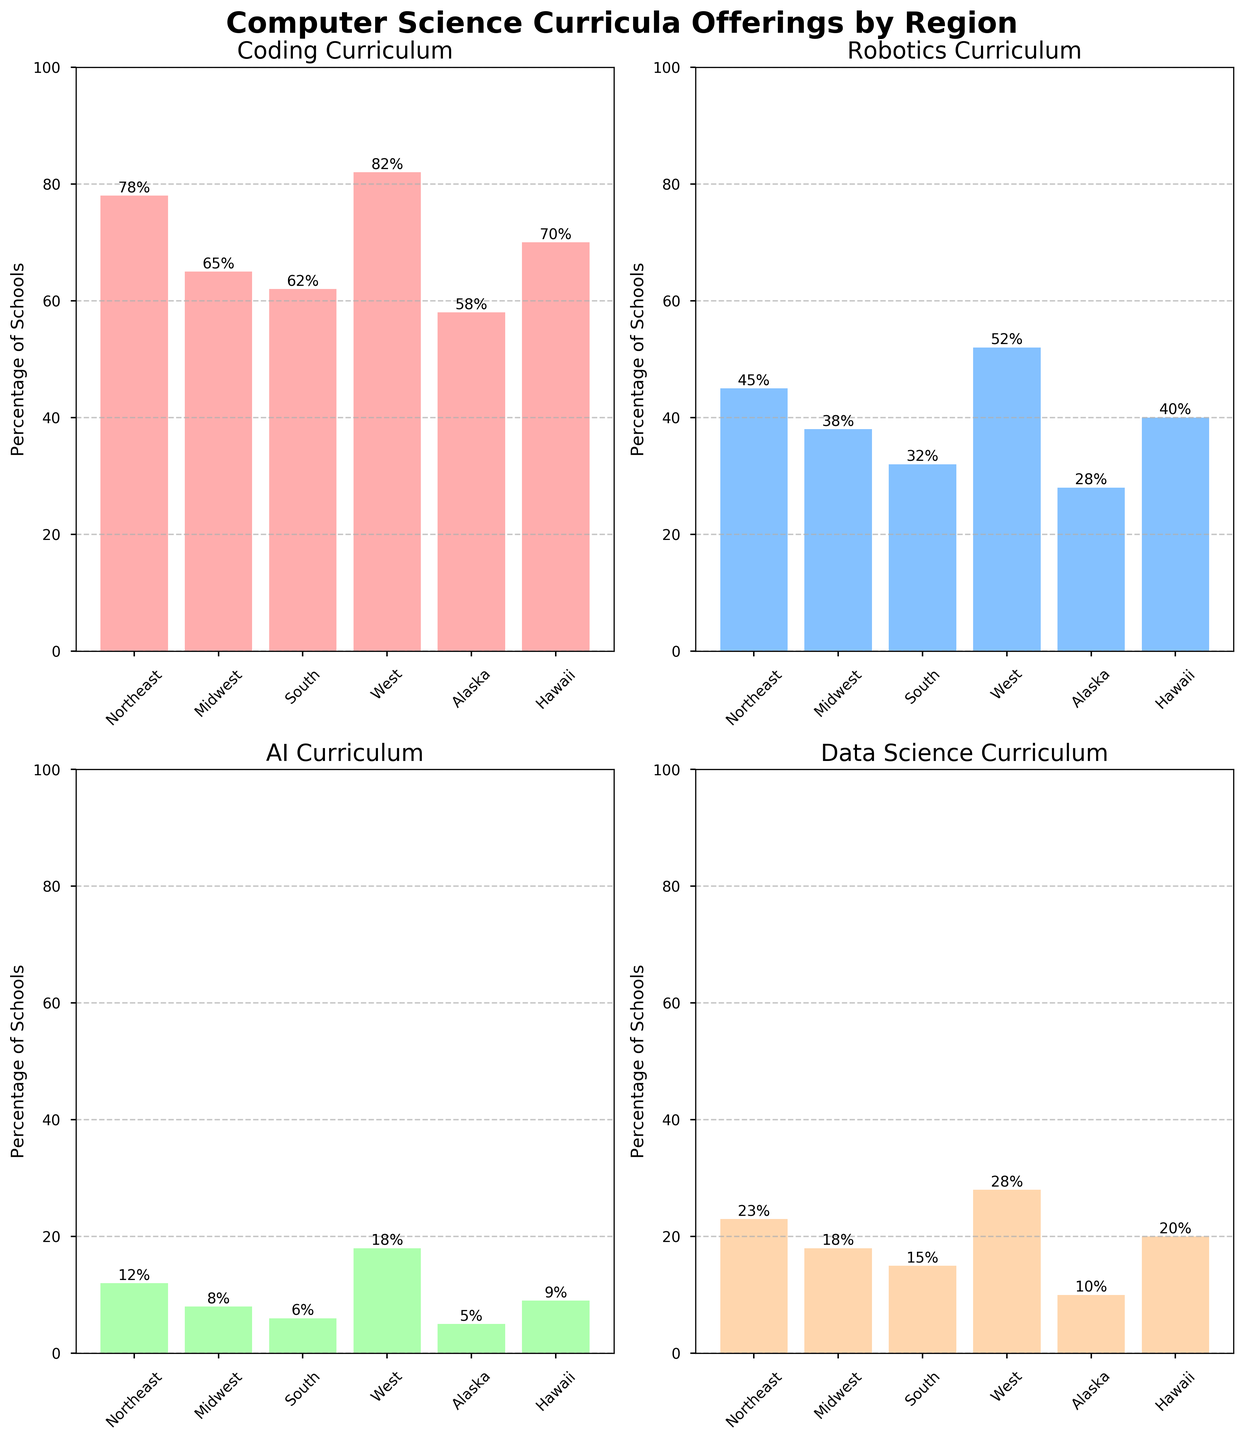What's the title of the figure? The title of the figure is usually found at the top center, often in a larger and bold font. In this specific figure, the title is "Computer Science Curricula Offerings by Region".
Answer: Computer Science Curricula Offerings by Region What percentage of schools in the West offer AI curricula? Identify the bar corresponding to the West region in the AI subplot and read the height of the bar, which represents the percentage. The bar reaches up to 18%.
Answer: 18% Which region has the highest percentage of schools offering Coding curricula? Compare the heights of the bars in the Coding subplot for all regions. The West region has the tallest bar at 82%.
Answer: West What is the difference in percentage of schools offering Robotics curricula between the West and Alaska? Identify the Robotics percentages for the West (52%) and Alaska (28%) regions, then subtract the smaller value from the larger one. 52% - 28% = 24%.
Answer: 24% Which curriculum has the least percentage of schools offering it in the South region? Compare the percentages in the South region across all subplots. AI has the lowest percentage at 6%.
Answer: AI How many curricula are offered by more than 70% of schools in the West region? Check the West region percentages across all subplots. Both Coding (82%) and Data Science (28%) surpass 70%. So only Coding.
Answer: 1 Which regions offer Data Science curricula in less than 20% of schools? Identify which regions have percentages below 20% in the Data Science subplot: Midwest (18%), South (15%), Alaska (10%), and Hawaii (20%) just on the border. Hence, Alaska, Midwest, and South.
Answer: Midwest, South, Alaska What is the average percentage of schools offering Coding curricula across all regions? Sum the percentages for Coding for all regions and divide by the number of regions. (78 + 65 + 62 + 82 + 58 + 70) / 6 = 69.17%
Answer: 69.17% Does the Midwest or Northeast have a higher percentage of schools offering AI curricula? Compare the percentages in the AI subplot for Midwest (8%) and Northeast (12%). The Northeast has a higher percentage.
Answer: Northeast What's the combined percentage of schools in Hawaii offering Coding and Robotics curricula? Add the percentages for Coding (70%) and Robotics (40%) in Hawaii. 70% + 40% = 110%
Answer: 110% 